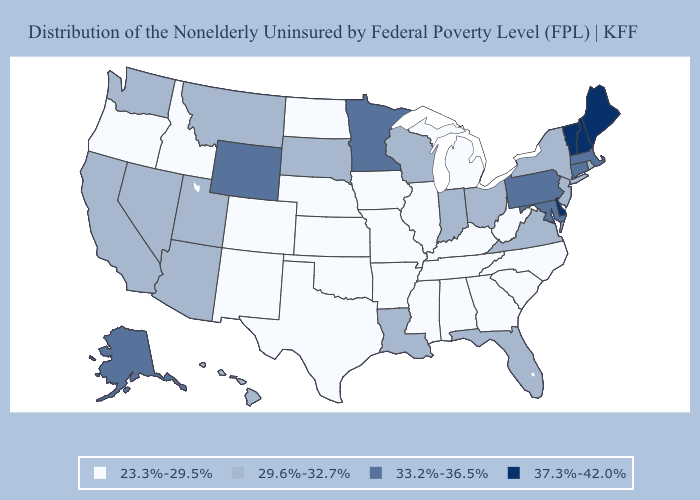Which states hav the highest value in the West?
Be succinct. Alaska, Wyoming. Name the states that have a value in the range 23.3%-29.5%?
Be succinct. Alabama, Arkansas, Colorado, Georgia, Idaho, Illinois, Iowa, Kansas, Kentucky, Michigan, Mississippi, Missouri, Nebraska, New Mexico, North Carolina, North Dakota, Oklahoma, Oregon, South Carolina, Tennessee, Texas, West Virginia. Does Louisiana have a higher value than West Virginia?
Concise answer only. Yes. What is the value of Michigan?
Concise answer only. 23.3%-29.5%. Name the states that have a value in the range 33.2%-36.5%?
Short answer required. Alaska, Connecticut, Maryland, Massachusetts, Minnesota, Pennsylvania, Wyoming. Does Ohio have a lower value than Delaware?
Give a very brief answer. Yes. Among the states that border North Dakota , does Minnesota have the highest value?
Give a very brief answer. Yes. Name the states that have a value in the range 33.2%-36.5%?
Quick response, please. Alaska, Connecticut, Maryland, Massachusetts, Minnesota, Pennsylvania, Wyoming. Among the states that border Pennsylvania , which have the lowest value?
Keep it brief. West Virginia. What is the lowest value in states that border California?
Short answer required. 23.3%-29.5%. How many symbols are there in the legend?
Keep it brief. 4. Does Arizona have the highest value in the USA?
Be succinct. No. Does Arkansas have the highest value in the South?
Answer briefly. No. Name the states that have a value in the range 37.3%-42.0%?
Write a very short answer. Delaware, Maine, New Hampshire, Vermont. 